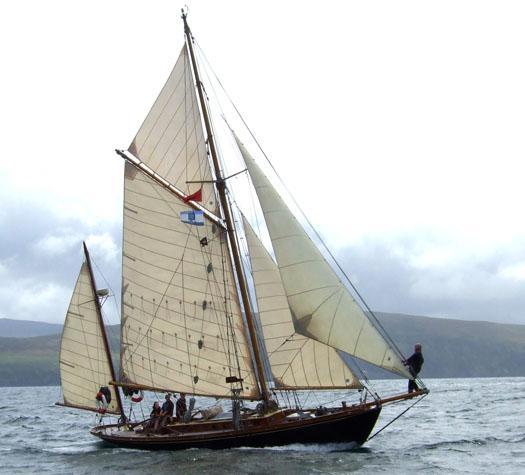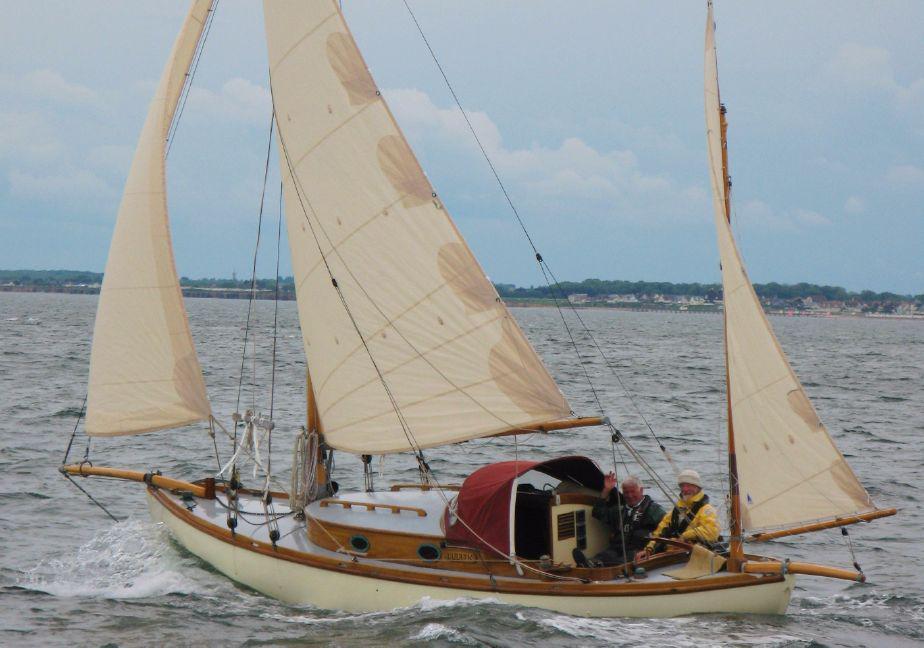The first image is the image on the left, the second image is the image on the right. Analyze the images presented: Is the assertion "There are no more than three sails." valid? Answer yes or no. No. The first image is the image on the left, the second image is the image on the right. Assess this claim about the two images: "The left and right image contains the same number of sailboats with open sails.". Correct or not? Answer yes or no. Yes. 